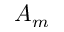<formula> <loc_0><loc_0><loc_500><loc_500>A _ { m }</formula> 